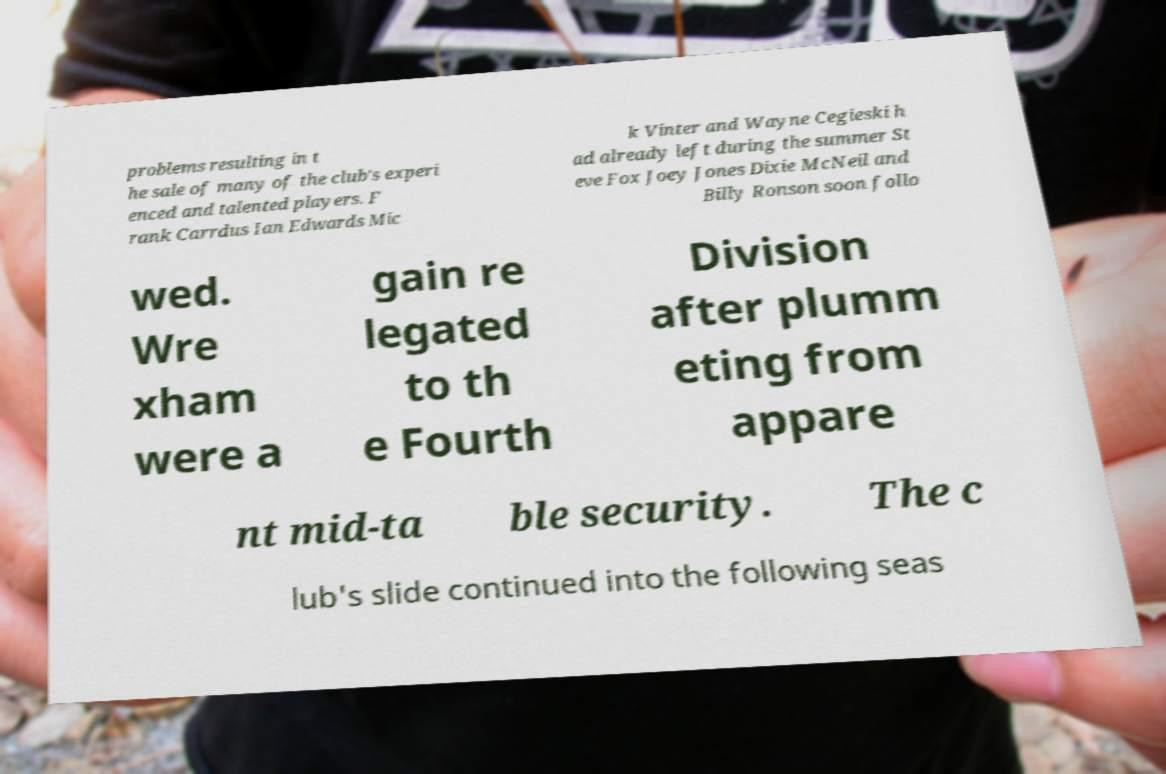Can you read and provide the text displayed in the image?This photo seems to have some interesting text. Can you extract and type it out for me? problems resulting in t he sale of many of the club's experi enced and talented players. F rank Carrdus Ian Edwards Mic k Vinter and Wayne Cegieski h ad already left during the summer St eve Fox Joey Jones Dixie McNeil and Billy Ronson soon follo wed. Wre xham were a gain re legated to th e Fourth Division after plumm eting from appare nt mid-ta ble security. The c lub's slide continued into the following seas 